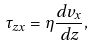Convert formula to latex. <formula><loc_0><loc_0><loc_500><loc_500>\tau _ { z x } = \eta \frac { d v _ { x } } { d z } ,</formula> 